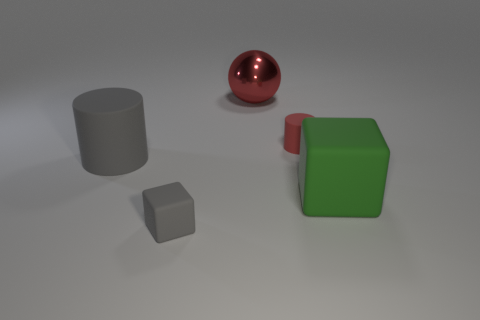What material is the thing that is the same color as the large matte cylinder?
Your response must be concise. Rubber. How many cubes are big green things or small things?
Provide a succinct answer. 2. Is the big green thing made of the same material as the tiny gray object?
Your answer should be compact. Yes. How many other objects are there of the same color as the small cylinder?
Provide a succinct answer. 1. There is a tiny thing that is in front of the large green cube; what is its shape?
Offer a very short reply. Cube. What number of things are large red metal cylinders or large rubber cylinders?
Provide a short and direct response. 1. There is a red shiny thing; is it the same size as the gray rubber thing behind the big block?
Your response must be concise. Yes. How many other objects are the same material as the big red sphere?
Give a very brief answer. 0. What number of objects are either large matte objects that are right of the tiny red matte cylinder or matte cubes that are behind the gray block?
Your response must be concise. 1. What material is the big gray thing that is the same shape as the red rubber thing?
Ensure brevity in your answer.  Rubber. 